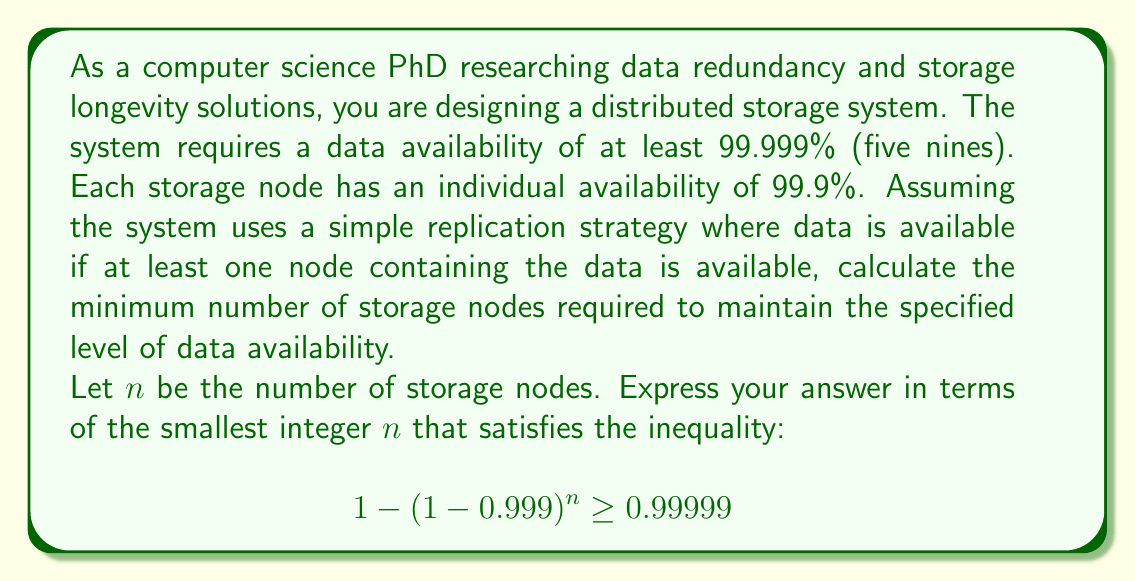Could you help me with this problem? To solve this problem, we need to follow these steps:

1) The probability of data being unavailable on a single node is $1 - 0.999 = 0.001$.

2) For the data to be unavailable in the entire system, it must be unavailable on all $n$ nodes. The probability of this is $(0.001)^n$.

3) Therefore, the probability of data being available is $1 - (0.001)^n$.

4) We want this probability to be at least 0.99999, so we can set up the inequality:

   $$ 1 - (0.001)^n \geq 0.99999 $$

5) Subtracting both sides from 1:

   $$ (0.001)^n \leq 0.00001 $$

6) Taking the logarithm of both sides:

   $$ n \log(0.001) \leq \log(0.00001) $$

7) Dividing both sides by $\log(0.001)$ (note that this flips the inequality because $\log(0.001)$ is negative):

   $$ n \geq \frac{\log(0.00001)}{\log(0.001)} \approx 4.9999 $$

8) Since $n$ must be an integer, we round up to the nearest whole number.

Therefore, the minimum number of storage nodes required is the smallest integer $n$ that satisfies $n \geq 5$.
Answer: The minimum number of storage nodes required is 5. 